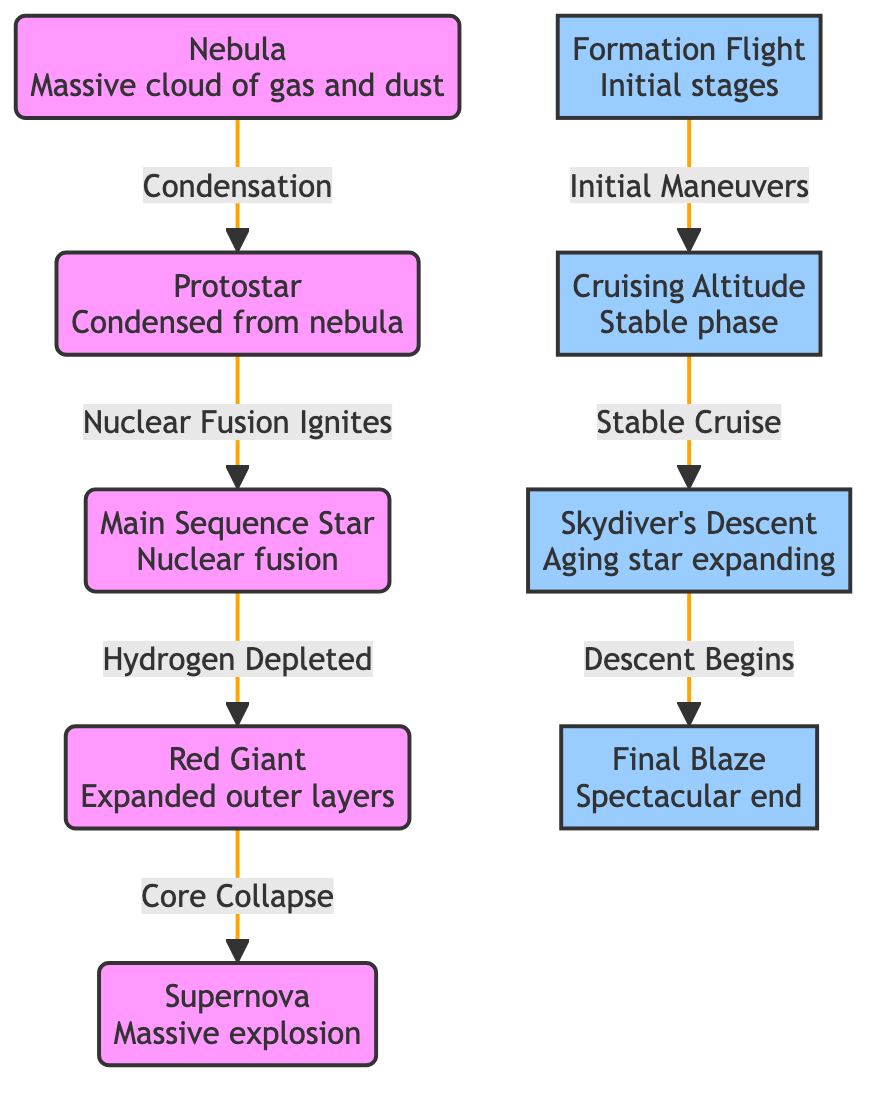What is the first stage in the star life cycle? The diagram starts with the "Nebula" node, which represents the initial stage of star formation.
Answer: Nebula How many main stages are depicted in the star life cycle? By counting the nodes in the flow from the nebula to the supernova, there are five main stages: Nebula, Protostar, Main Sequence Star, Red Giant, and Supernova.
Answer: Five What is the relationship between a protostar and a main sequence star? The diagram shows an arrow from the "Protostar" node to the "Main Sequence Star" node, indicating that the protostar evolves into a main sequence star once nuclear fusion ignites.
Answer: Nuclear Fusion Ignites What happens to a main sequence star when hydrogen is depleted? According to the diagram, when a main sequence star depletes hydrogen, it progresses to the next stage represented by the "Red Giant" node.
Answer: Red Giant What is the name of the stage marked by the core collapse? The diagram indicates that after the red giant stage, a "Core Collapse" leads to the "Supernova" stage, which is marked by a massive explosion.
Answer: Supernova What is the second flight trajectory represented in the diagram? The second flight trajectory labeled in the diagram is "Cruising Altitude," which corresponds to the stable phase of a main sequence star.
Answer: Cruising Altitude What does the "Skydiver's Descent" trajectory represent? This trajectory describes the aging star expanding as it transitions from the red giant phase to the supernova phase.
Answer: Aging star expanding What happens after the "Stable Cruise" in the star life cycle? Following the "Stable Cruise," there is a transition to "Descent Begins," which indicates the aging process of the star leading to its eventual supernova stage.
Answer: Descent Begins Which stage signifies the final end of the star's life cycle? The diagram visually portrays that the "Final Blaze" corresponds to the "Supernova," representing the spectacular end of the star's life cycle.
Answer: Final Blaze 